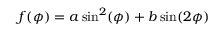Convert formula to latex. <formula><loc_0><loc_0><loc_500><loc_500>f ( \phi ) = a \sin ^ { 2 } ( \phi ) + b \sin ( 2 \phi )</formula> 